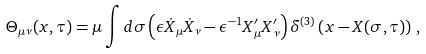Convert formula to latex. <formula><loc_0><loc_0><loc_500><loc_500>\Theta _ { \mu \nu } ( { x } , \tau ) = \mu \int d \sigma \left ( \epsilon \dot { X } _ { \mu } \dot { X } _ { \nu } - \epsilon ^ { - 1 } { X } ^ { \prime } _ { \mu } { X } ^ { \prime } _ { \nu } \right ) \delta ^ { ( 3 ) } \left ( { x } - { X } ( \sigma , \tau ) \right ) \, ,</formula> 